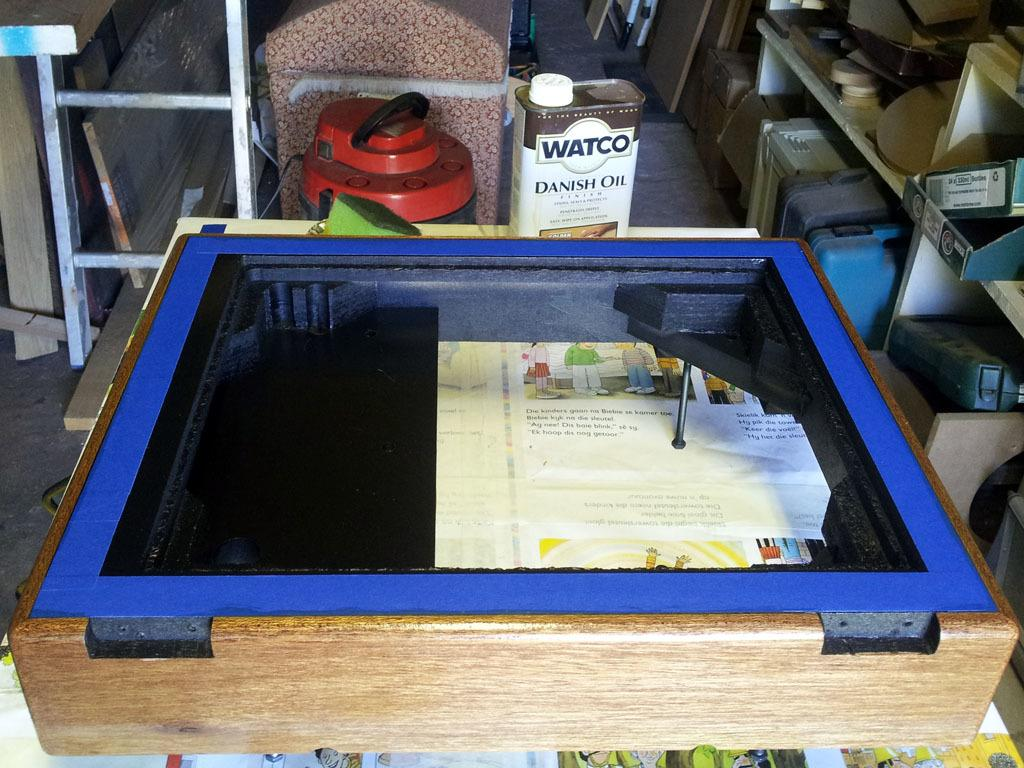What type of container is in the image? There is a wooden box in the image. What is inside the wooden box? There are papers inside the wooden box. What can be seen in the background of the image? There are bottles visible in the background of the image. What is present in the racks? There are objects present in the racks. How does the thumb help in measuring the papers inside the wooden box? There is no thumb present in the image, and the papers are not being measured. 